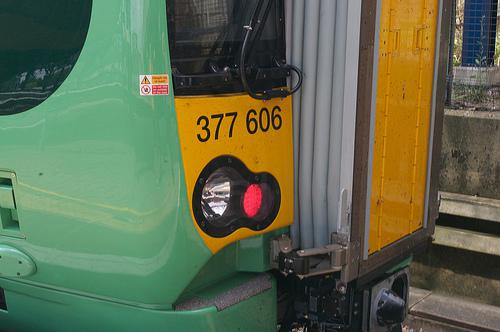Question: where are the numbers?
Choices:
A. Side of the car.
B. Back window.
C. Hood of car.
D. Back of the train car.
Answer with the letter. Answer: D Question: why is there a train?
Choices:
A. Transportation.
B. To transport people.
C. Public transportion.
D. Traveling.
Answer with the letter. Answer: B Question: what are the first three numbers?
Choices:
A. 376.
B. 378.
C. 377.
D. 375.
Answer with the letter. Answer: C Question: how many numbers are there?
Choices:
A. Six.
B. Seven.
C. Eight.
D. Five.
Answer with the letter. Answer: A Question: who drives the train?
Choices:
A. Engineer.
B. Conductor.
C. Man.
D. Woman.
Answer with the letter. Answer: A 